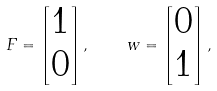Convert formula to latex. <formula><loc_0><loc_0><loc_500><loc_500>F = \begin{bmatrix} 1 \\ 0 \end{bmatrix} , \quad w = \begin{bmatrix} 0 \\ 1 \end{bmatrix} ,</formula> 